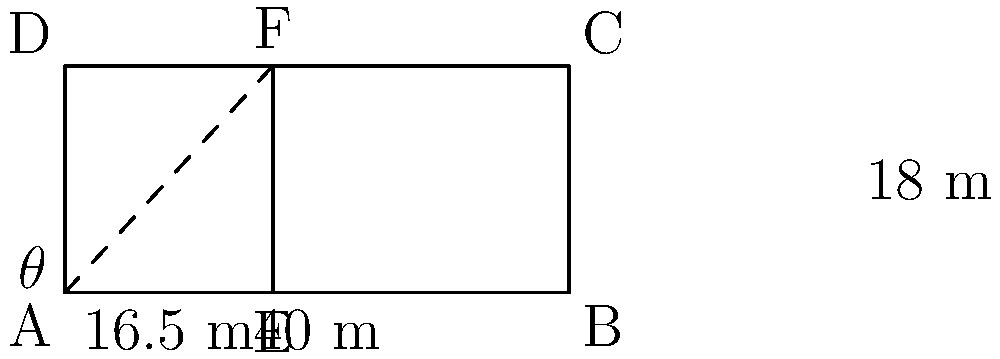In a football pitch, the penalty box is rectangular. Given that the width of the penalty box is 40 meters and the distance from the goal line to the penalty spot is 11 meters, calculate the area of the penalty box. Use the fact that the angle $\theta$ formed by the corner flag, the penalty spot, and the nearest point on the touchline is 30°. Let's approach this step-by-step:

1) First, we need to find the length of the penalty box. We can do this using trigonometry.

2) In the right triangle formed by the corner flag, the penalty spot, and the point where the penalty arc meets the touchline:
   - The adjacent side is 11 meters (distance from goal line to penalty spot)
   - We know the angle $\theta$ is 30°
   
3) We can use the tangent ratio:
   
   $\tan 30° = \frac{\text{opposite}}{\text{adjacent}} = \frac{\text{half width of penalty box}}{11}$

4) We know that $\tan 30° = \frac{1}{\sqrt{3}}$, so:

   $\frac{1}{\sqrt{3}} = \frac{\text{half width}}{11}$

5) Solving for the half width:

   $\text{half width} = 11 \cdot \frac{1}{\sqrt{3}} = \frac{11}{\sqrt{3}} \approx 6.35$ meters

6) The full width is twice this: $2 \cdot \frac{11}{\sqrt{3}} = \frac{22}{\sqrt{3}} \approx 12.7$ meters

7) However, we're given that the actual width is 40 meters. This means the length we calculated (12.7 m) corresponds to the distance from the goal line to where the penalty arc meets the touchline.

8) The full length of the penalty box is 18 meters (16.5 m + 1.5 m, where 1.5 m is the radius of the penalty arc).

9) Now we can calculate the area:
   
   Area = length $\times$ width = 18 $\times$ 40 = 720 square meters
Answer: 720 m² 